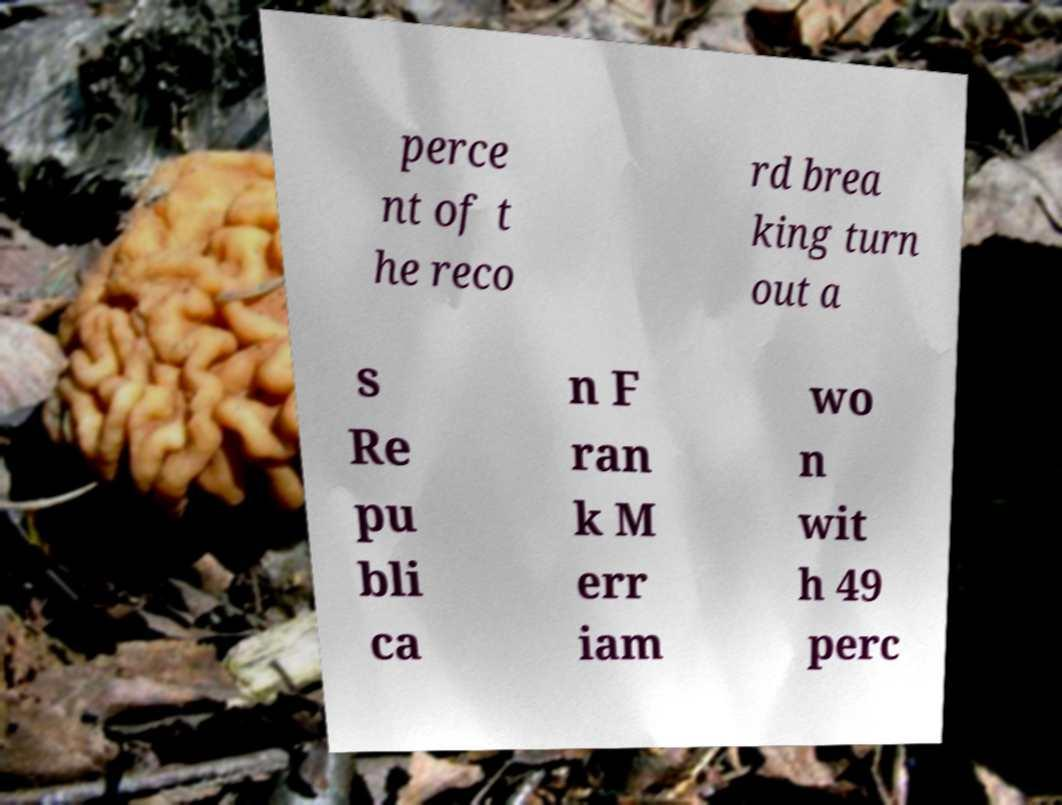Could you assist in decoding the text presented in this image and type it out clearly? perce nt of t he reco rd brea king turn out a s Re pu bli ca n F ran k M err iam wo n wit h 49 perc 